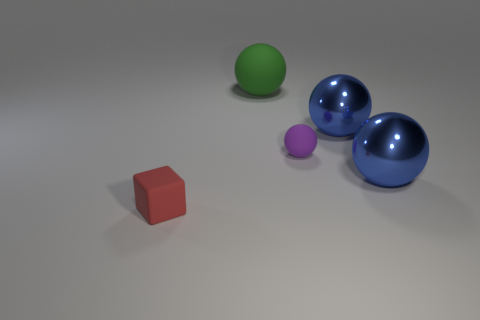The blue thing behind the small object that is behind the red block is made of what material?
Your answer should be very brief. Metal. Do the red object and the green matte sphere have the same size?
Your answer should be very brief. No. How many objects are either large balls that are on the right side of the green thing or big blue spheres?
Give a very brief answer. 2. The tiny thing to the left of the rubber thing on the right side of the green rubber sphere is what shape?
Your answer should be compact. Cube. There is a purple sphere; does it have the same size as the object that is on the left side of the big green thing?
Your answer should be compact. Yes. There is a blue sphere that is behind the small purple rubber ball; what material is it?
Your answer should be very brief. Metal. What number of things are on the left side of the purple sphere and behind the red rubber thing?
Provide a short and direct response. 1. There is a thing that is the same size as the red cube; what material is it?
Offer a terse response. Rubber. There is a blue shiny thing in front of the small purple sphere; is it the same size as the matte sphere behind the tiny purple sphere?
Provide a short and direct response. Yes. There is a purple rubber sphere; are there any rubber things behind it?
Your answer should be very brief. Yes. 